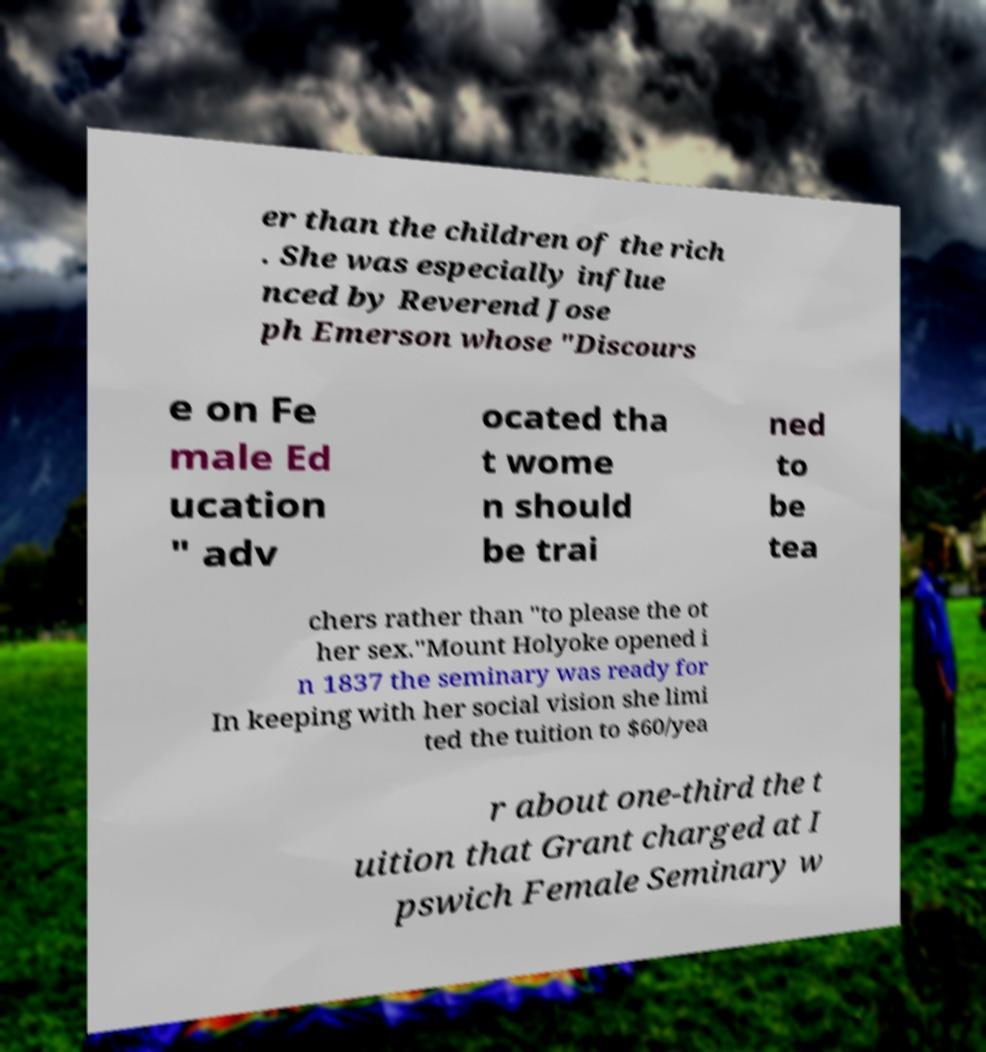Could you extract and type out the text from this image? er than the children of the rich . She was especially influe nced by Reverend Jose ph Emerson whose "Discours e on Fe male Ed ucation " adv ocated tha t wome n should be trai ned to be tea chers rather than "to please the ot her sex."Mount Holyoke opened i n 1837 the seminary was ready for In keeping with her social vision she limi ted the tuition to $60/yea r about one-third the t uition that Grant charged at I pswich Female Seminary w 